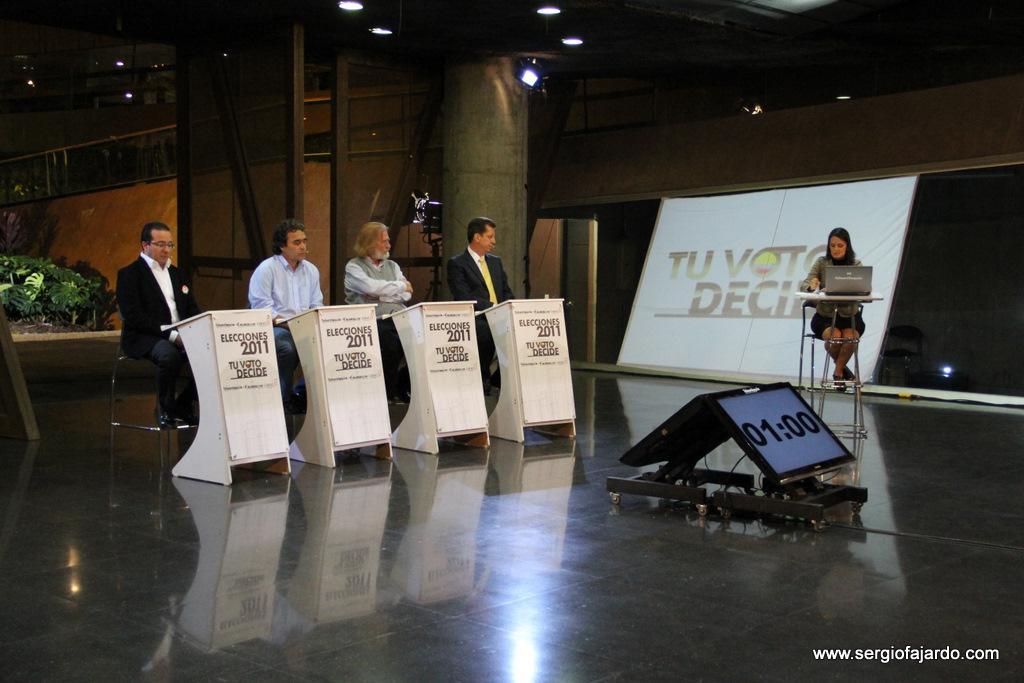Describe this image in one or two sentences. In this picture we can see four men sitting on chairs in front of podiums, we can see a monitor here, on the right side there is a woman sitting on a chair here, there is a laptop here, on the left side we can see a plant, there are some lights at the top of the picture. 